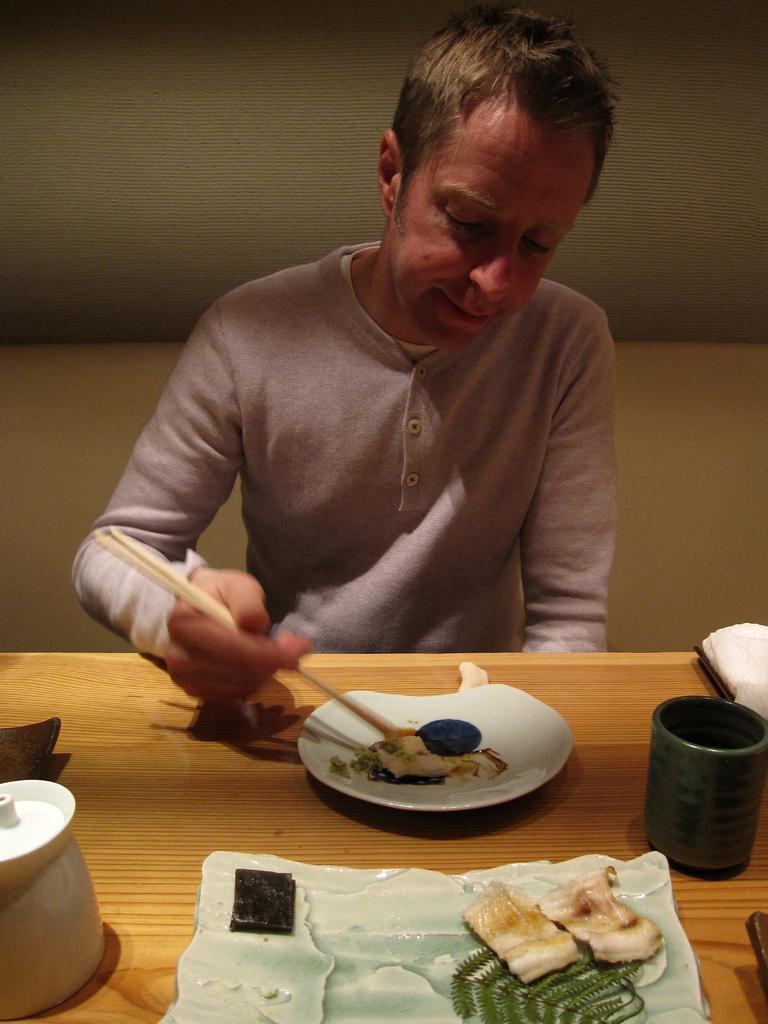Please provide a concise description of this image. In the picture we can see a man sitting in the chair near to the table and holding a chopsticks to have something which is on the plate and we can find cup, tissues, food on the table. The man is wearing a T-shirt. In the background we can see a wall. 